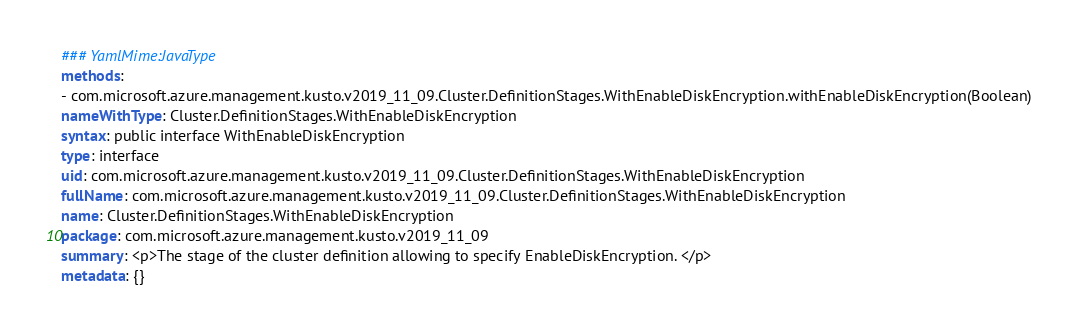<code> <loc_0><loc_0><loc_500><loc_500><_YAML_>### YamlMime:JavaType
methods:
- com.microsoft.azure.management.kusto.v2019_11_09.Cluster.DefinitionStages.WithEnableDiskEncryption.withEnableDiskEncryption(Boolean)
nameWithType: Cluster.DefinitionStages.WithEnableDiskEncryption
syntax: public interface WithEnableDiskEncryption
type: interface
uid: com.microsoft.azure.management.kusto.v2019_11_09.Cluster.DefinitionStages.WithEnableDiskEncryption
fullName: com.microsoft.azure.management.kusto.v2019_11_09.Cluster.DefinitionStages.WithEnableDiskEncryption
name: Cluster.DefinitionStages.WithEnableDiskEncryption
package: com.microsoft.azure.management.kusto.v2019_11_09
summary: <p>The stage of the cluster definition allowing to specify EnableDiskEncryption. </p>
metadata: {}
</code> 